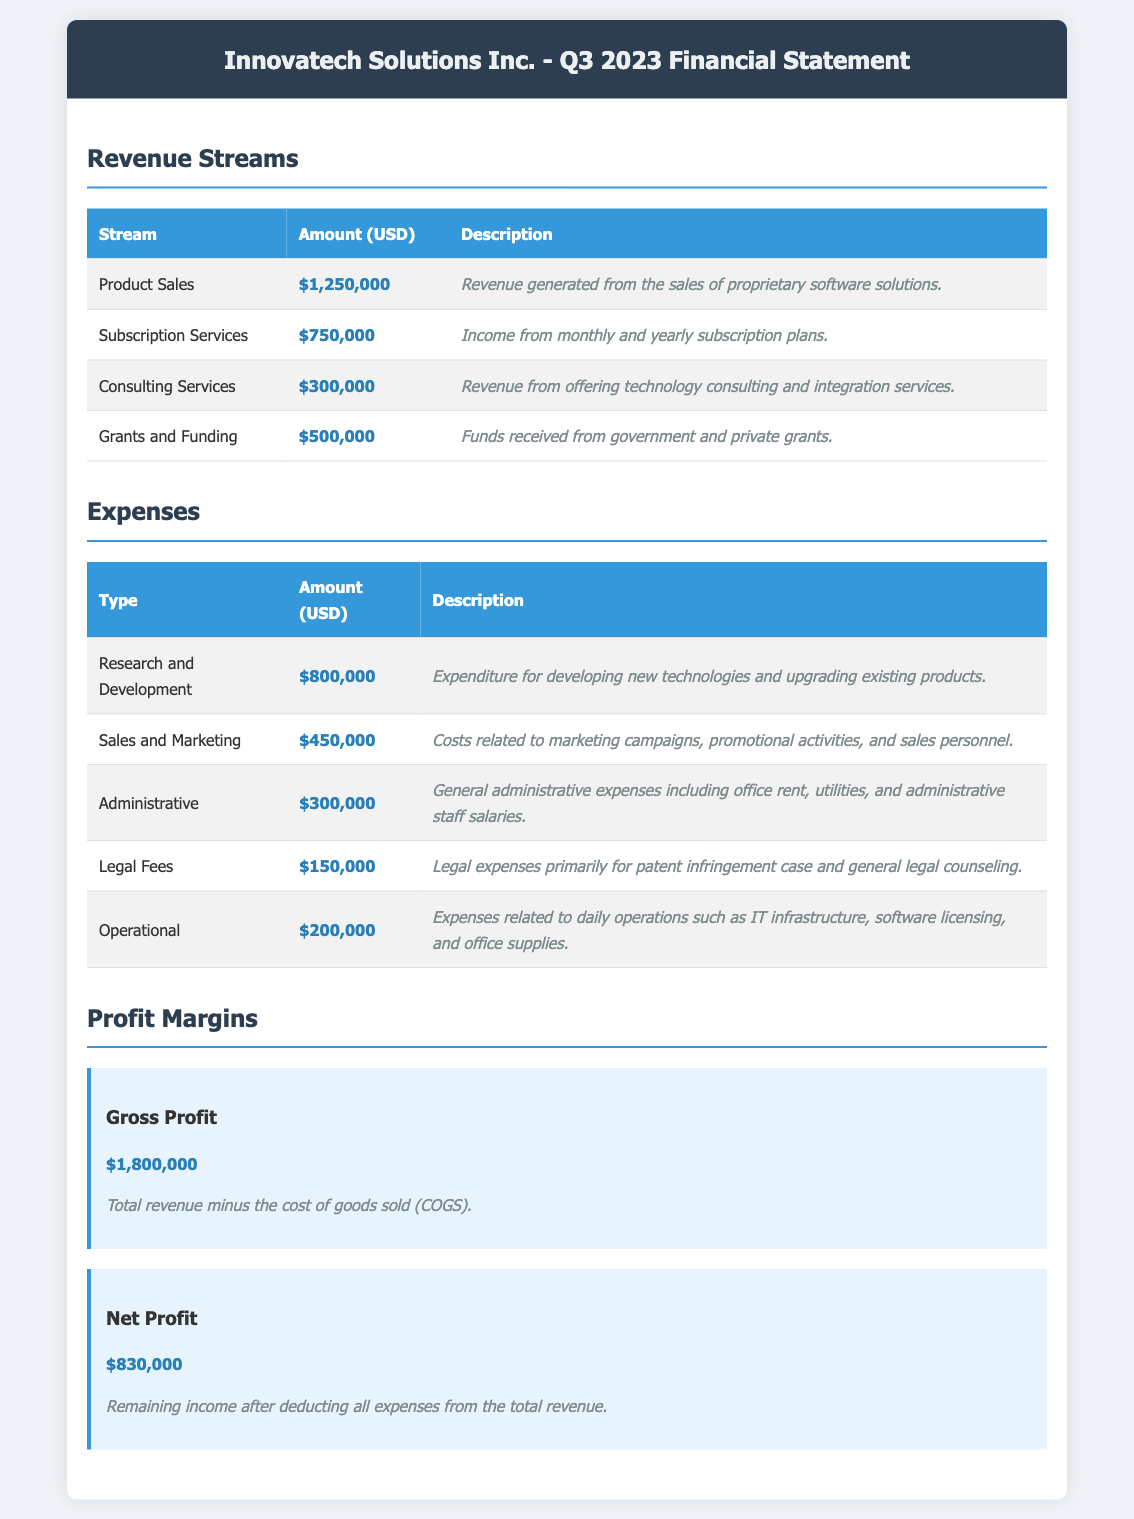What is the total revenue from Product Sales? The total revenue from Product Sales is specifically listed as $1,250,000.
Answer: $1,250,000 How much did the company earn from Subscription Services? The earnings from Subscription Services are detailed in the document as $750,000.
Answer: $750,000 What is the amount allocated for Research and Development? The amount for Research and Development is clearly provided as $800,000.
Answer: $800,000 What are the total expenses incurred by the company? The total expenses are derived from summing all types of expenses listed, which is $450,000 + $800,000 + $300,000 + $150,000 + $200,000 = $1,900,000.
Answer: $1,900,000 What is the Gross Profit as stated in the document? The Gross Profit is presented in the document as $1,800,000.
Answer: $1,800,000 What was the net profit for Q3 2023? The net profit reported for Q3 2023 is specified as $830,000.
Answer: $830,000 What percentage of total revenue comes from Grants and Funding? Grants and Funding account for $500,000 out of a total revenue of $2,750,000, representing approximately 18.18%.
Answer: 18.18% Which expense type has the highest value? The expense type with the highest value is Research and Development at $800,000.
Answer: Research and Development How many revenue streams are listed in the document? The document lists four distinct revenue streams.
Answer: Four What is the primary source of legal fees? The primary source of legal fees is stated as the patent infringement case.
Answer: Patent infringement case 